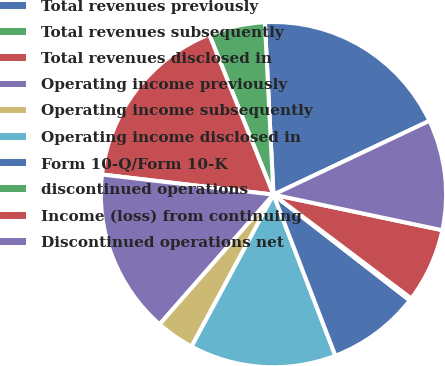Convert chart to OTSL. <chart><loc_0><loc_0><loc_500><loc_500><pie_chart><fcel>Total revenues previously<fcel>Total revenues subsequently<fcel>Total revenues disclosed in<fcel>Operating income previously<fcel>Operating income subsequently<fcel>Operating income disclosed in<fcel>Form 10-Q/Form 10-K<fcel>discontinued operations<fcel>Income (loss) from continuing<fcel>Discontinued operations net<nl><fcel>18.76%<fcel>5.28%<fcel>17.07%<fcel>15.39%<fcel>3.6%<fcel>13.71%<fcel>8.65%<fcel>0.23%<fcel>6.97%<fcel>10.34%<nl></chart> 